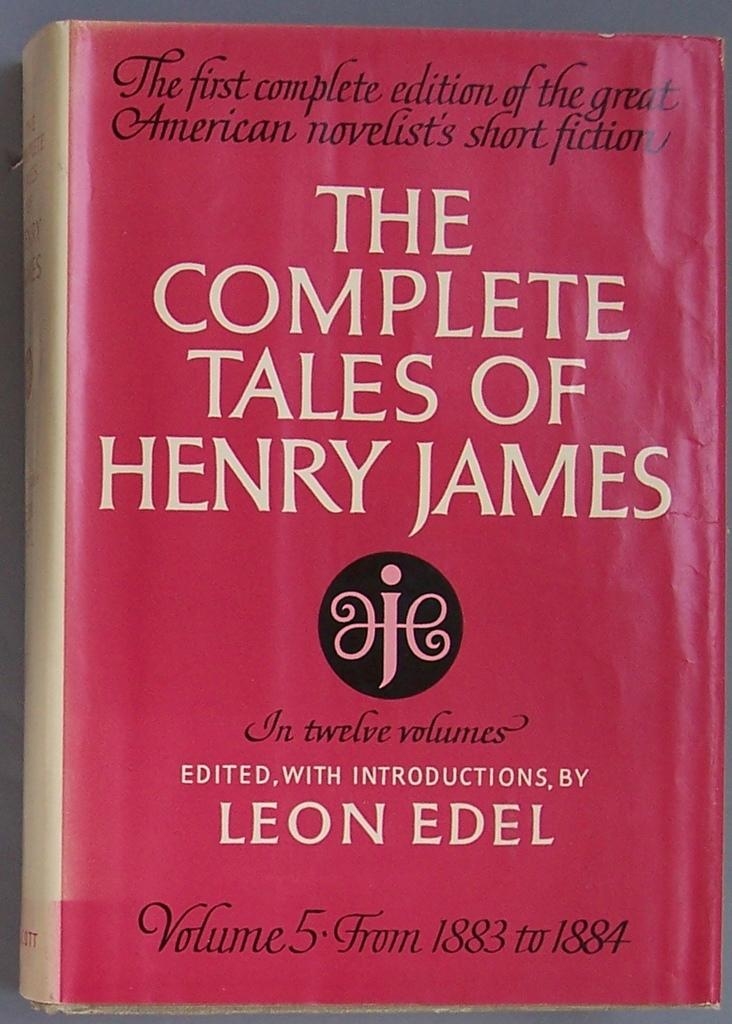<image>
Present a compact description of the photo's key features. book with red cover, the complete tales of henry james 